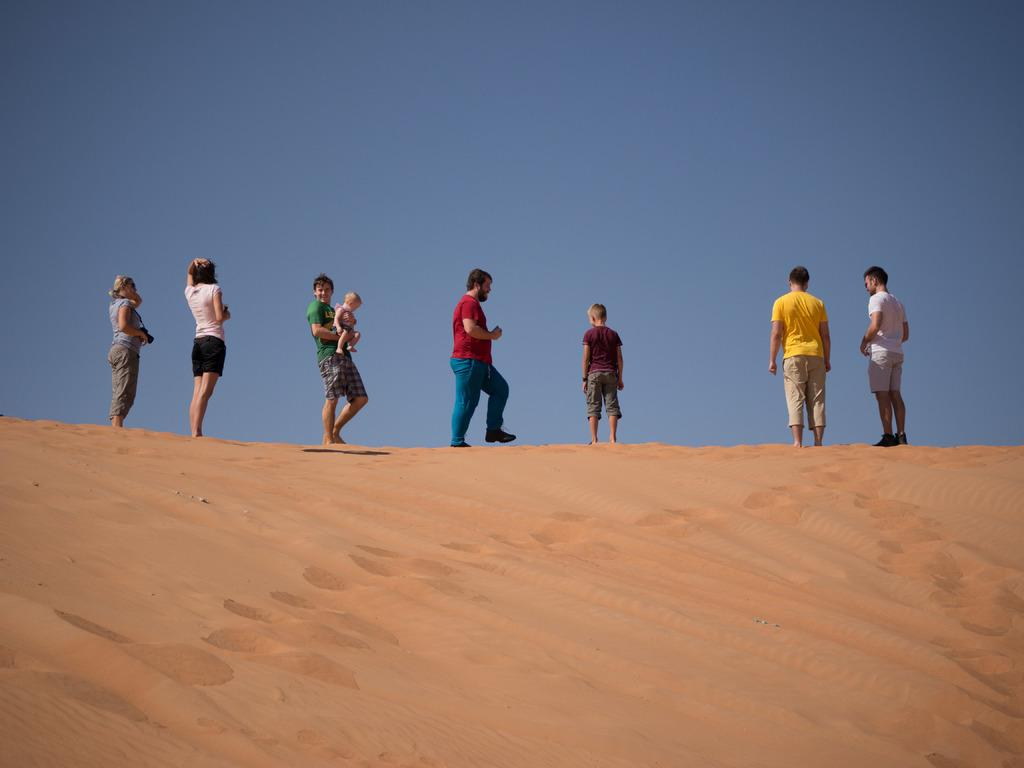How many people are in the image? There are many people in the image. What surface are the people standing on? The people are standing on the sand. What is visible at the top of the image? The sky is visible at the top of the image. What type of fang can be seen in the image? There is no fang present in the image. Can you tell me how much coal is being used in the image? There is no coal present in the image. 